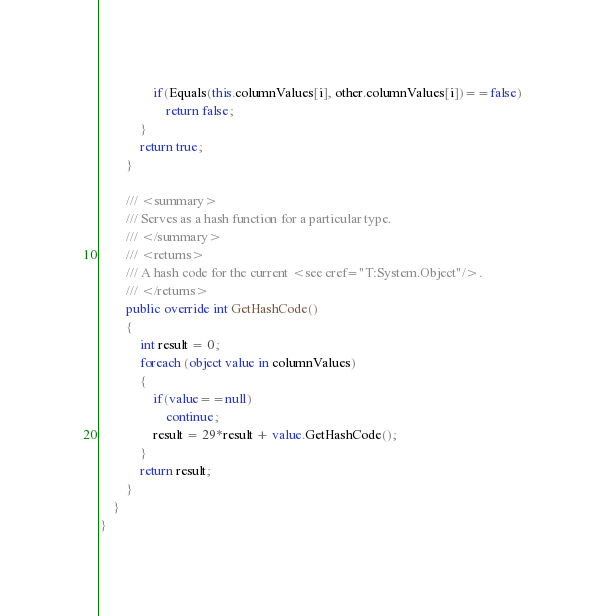<code> <loc_0><loc_0><loc_500><loc_500><_C#_>                if(Equals(this.columnValues[i], other.columnValues[i])==false)
                    return false;
            }
            return true;
        }

        /// <summary>
        /// Serves as a hash function for a particular type.
        /// </summary>
        /// <returns>
        /// A hash code for the current <see cref="T:System.Object"/>.
        /// </returns>
        public override int GetHashCode()
        {
            int result = 0;
            foreach (object value in columnValues)
            {
                if(value==null)
                    continue;
                result = 29*result + value.GetHashCode();
            }
            return result;
        }
    }
}</code> 